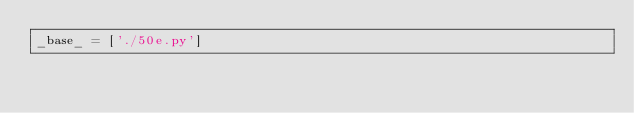Convert code to text. <code><loc_0><loc_0><loc_500><loc_500><_Python_>_base_ = ['./50e.py']
</code> 